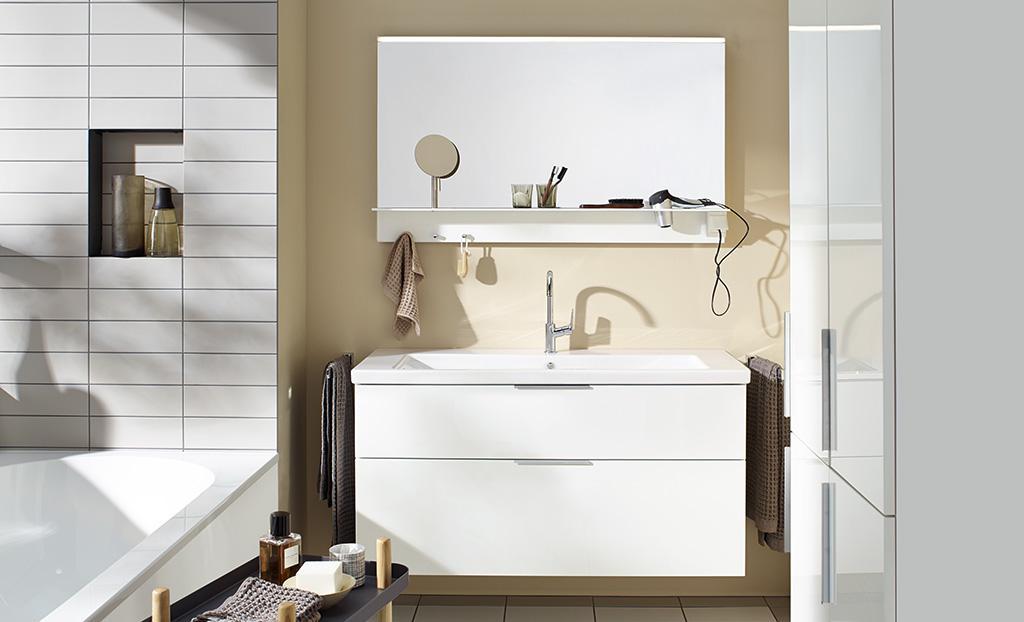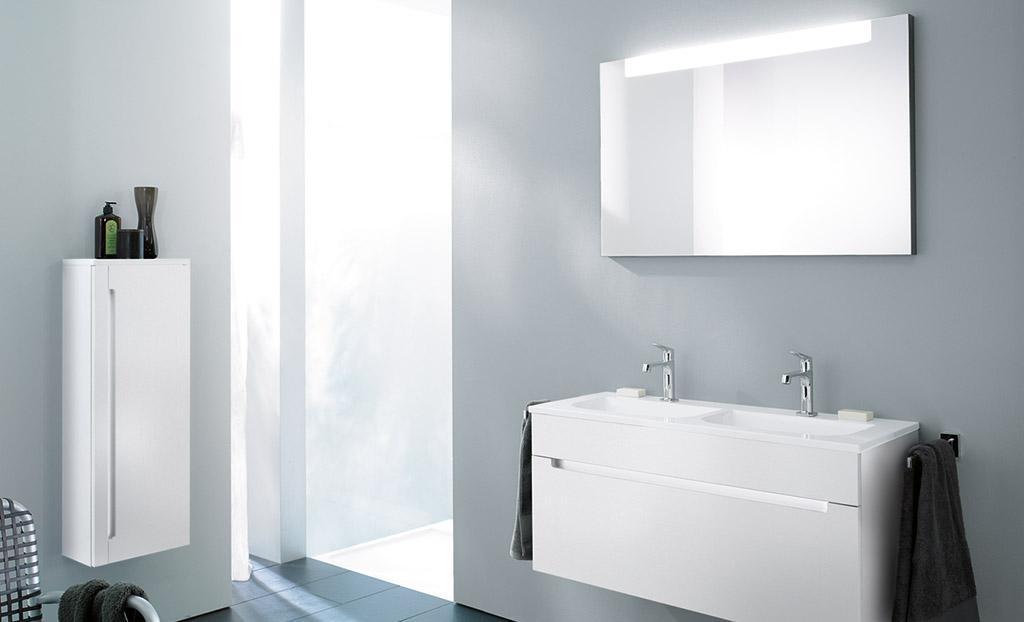The first image is the image on the left, the second image is the image on the right. Analyze the images presented: Is the assertion "In one image, a white vanity with white sink area has two chrome spout faucets and towels hanging on racks at each end of the vanity." valid? Answer yes or no. Yes. The first image is the image on the left, the second image is the image on the right. For the images shown, is this caption "The right image shows a top-view of a rectangular single-basin sink with a wall-mounted vanity that has a chrome towel bar on the side." true? Answer yes or no. No. 